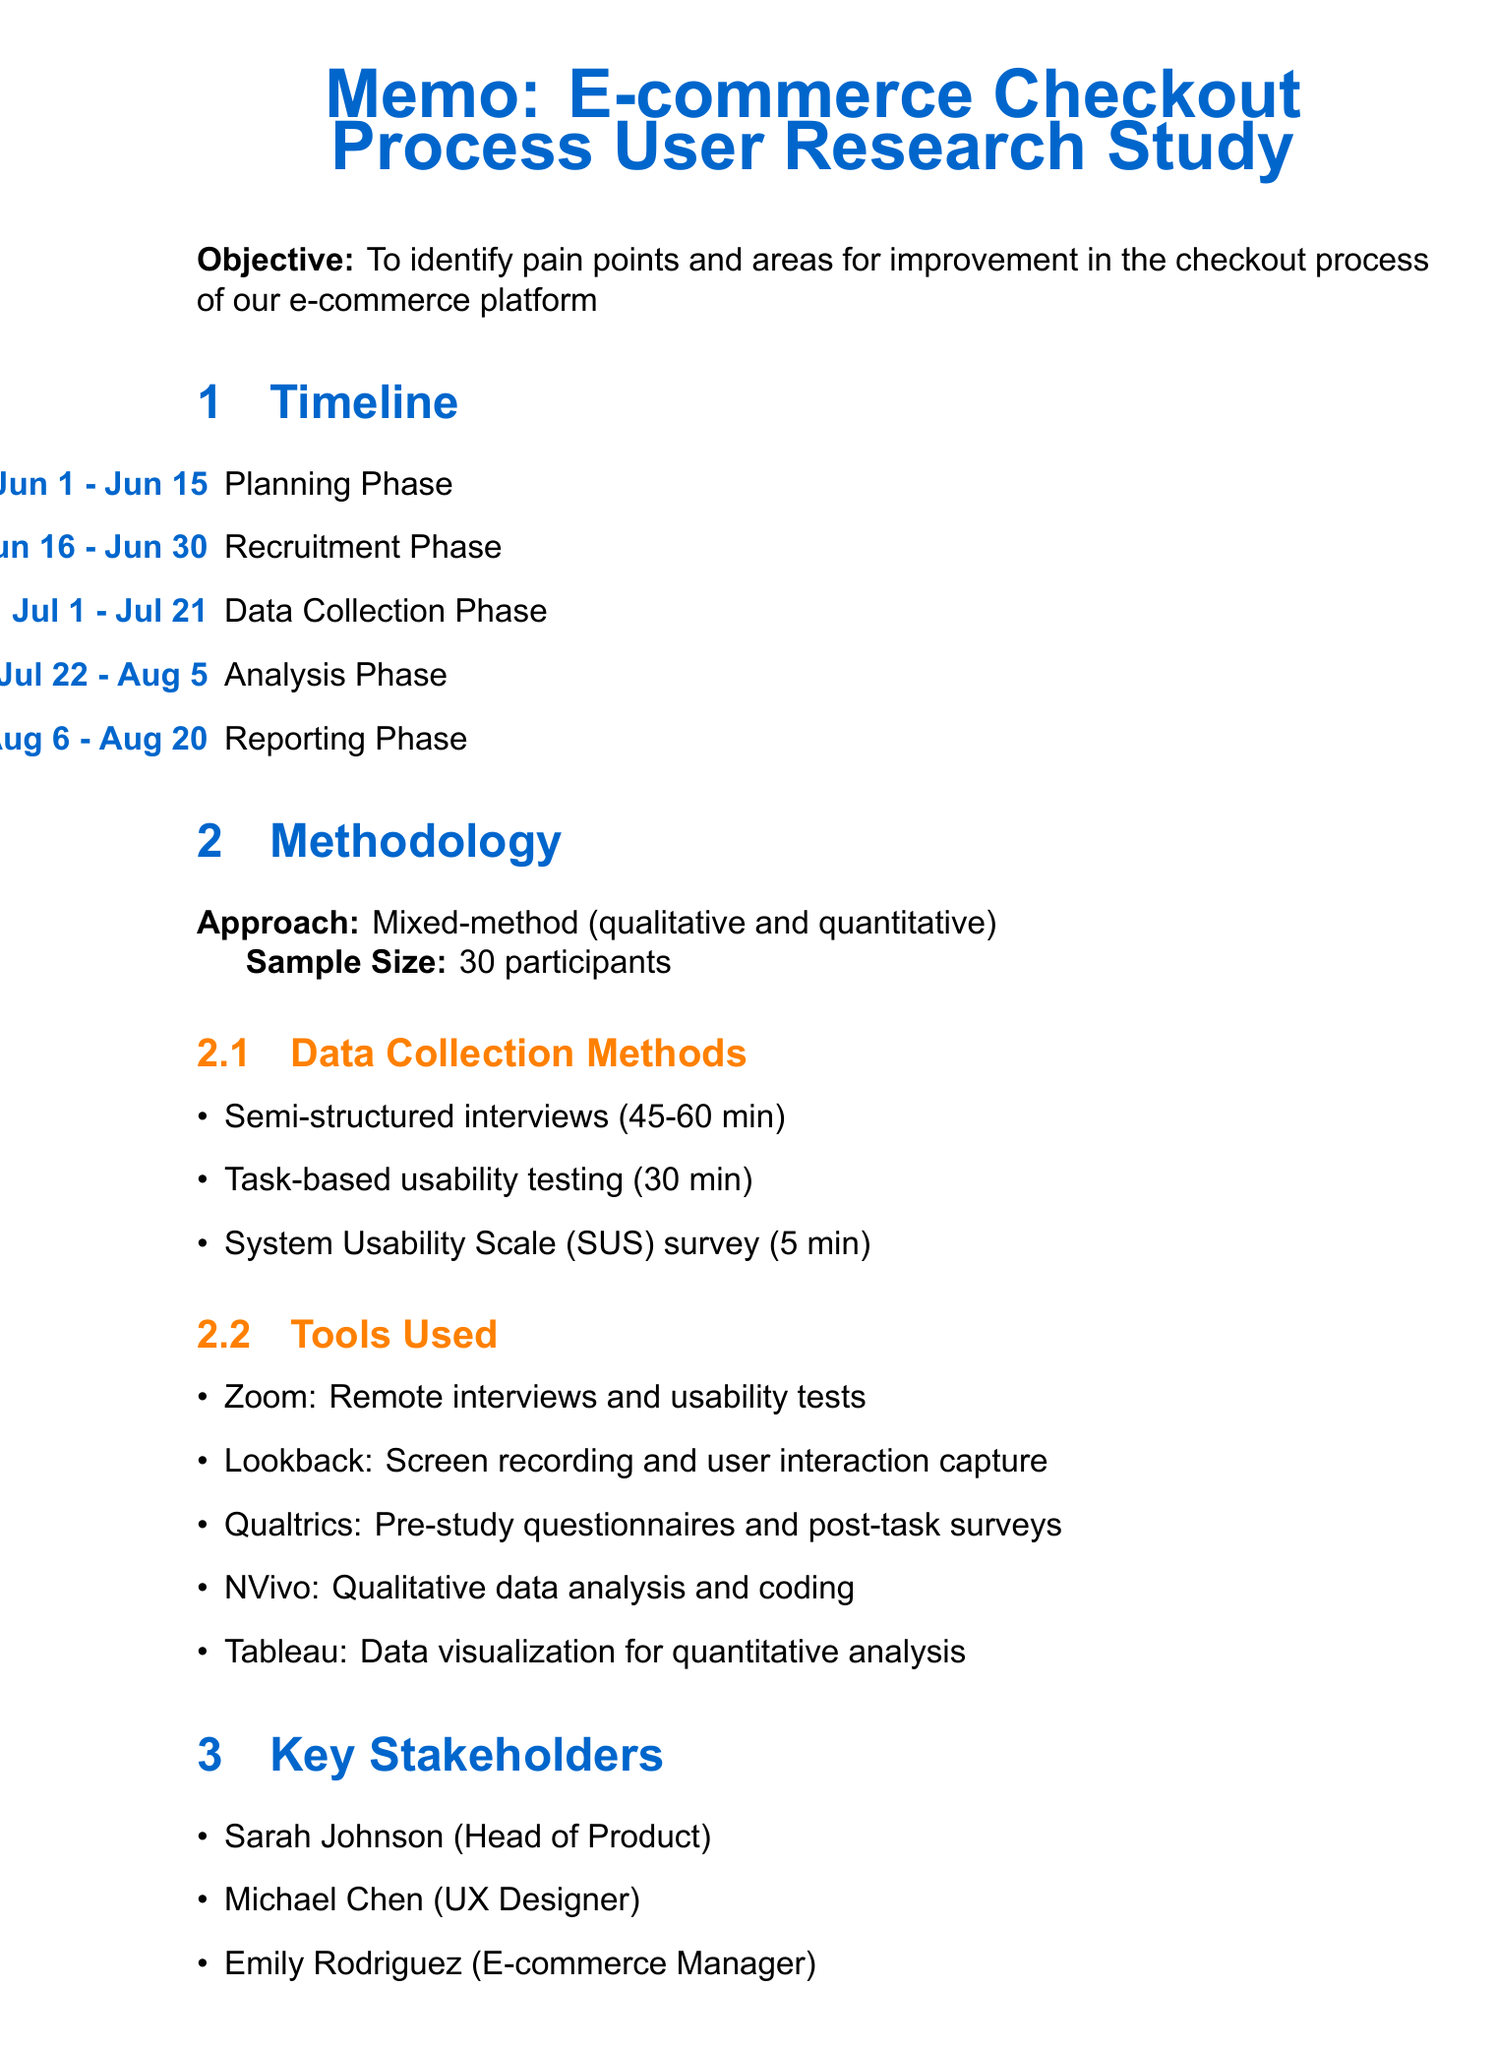What is the study title? The study title is stated at the beginning of the memo.
Answer: E-commerce Checkout Process User Research Study What is the start date of the data collection phase? The start date is specified in the timeline section under data collection phase.
Answer: July 1, 2023 Who is the e-commerce manager involved in the study? The document lists key stakeholders and their roles.
Answer: Emily Rodriguez How long will the analysis phase last? The duration is determined by the start and end dates mentioned in the timeline.
Answer: 15 days What methodology is being used for this study? The methodology section specifies the research approach utilized in the study.
Answer: Mixed-method approach combining qualitative and quantitative data How many participants are in the sample size? The sample size is mentioned in the methodology section of the memo.
Answer: 30 What tool is used for qualitative data analysis? The tools used for data collection and analysis are listed in the methodology section.
Answer: NVivo What will the user journey map highlight? The expected outcomes in the document outline key deliverables of the study.
Answer: Critical moments and emotions during checkout What is the focus of the semi-structured interviews? The data collection method section includes the focus of each method used.
Answer: Understanding user expectations and past experiences with e-commerce checkouts 